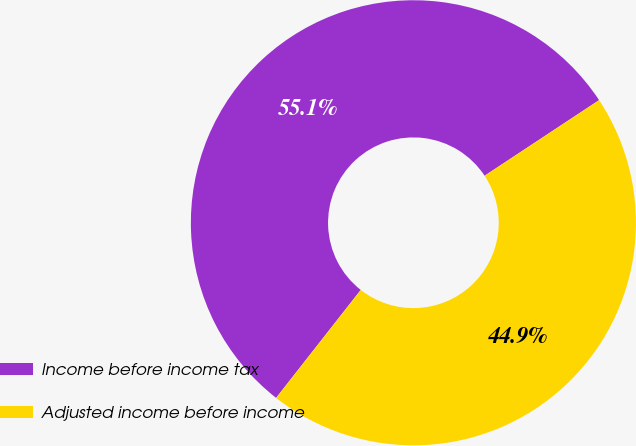<chart> <loc_0><loc_0><loc_500><loc_500><pie_chart><fcel>Income before income tax<fcel>Adjusted income before income<nl><fcel>55.13%<fcel>44.87%<nl></chart> 